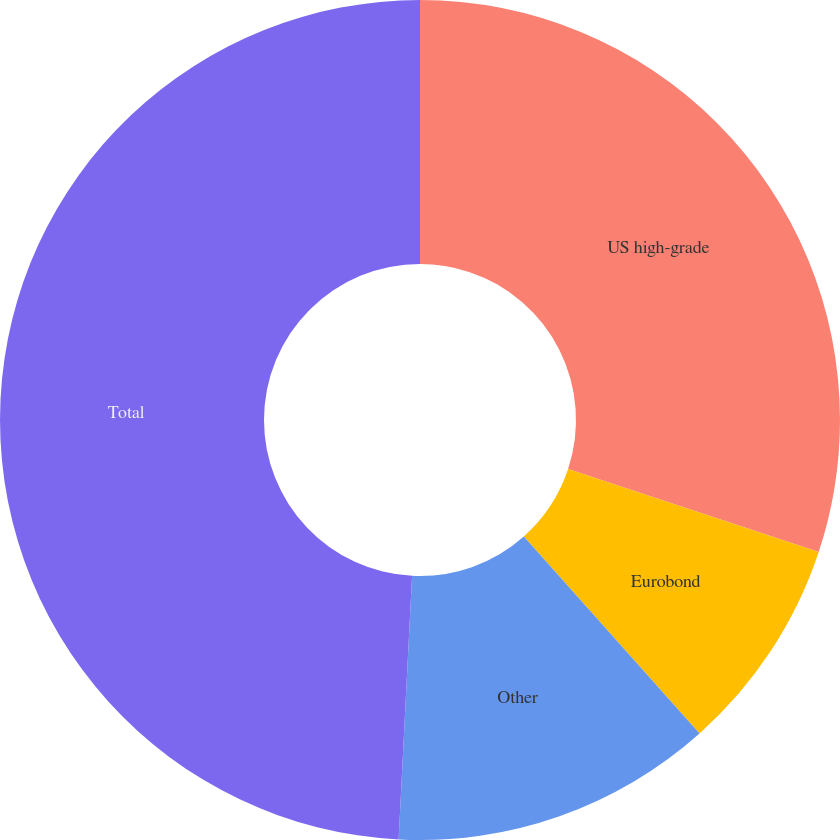Convert chart. <chart><loc_0><loc_0><loc_500><loc_500><pie_chart><fcel>US high-grade<fcel>Eurobond<fcel>Other<fcel>Total<nl><fcel>30.09%<fcel>8.32%<fcel>12.4%<fcel>49.19%<nl></chart> 